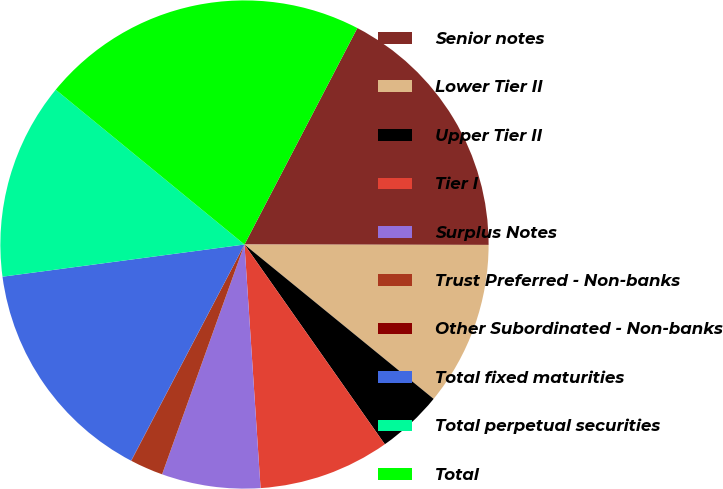Convert chart to OTSL. <chart><loc_0><loc_0><loc_500><loc_500><pie_chart><fcel>Senior notes<fcel>Lower Tier II<fcel>Upper Tier II<fcel>Tier I<fcel>Surplus Notes<fcel>Trust Preferred - Non-banks<fcel>Other Subordinated - Non-banks<fcel>Total fixed maturities<fcel>Total perpetual securities<fcel>Total<nl><fcel>17.38%<fcel>10.87%<fcel>4.36%<fcel>8.7%<fcel>6.53%<fcel>2.19%<fcel>0.02%<fcel>15.21%<fcel>13.04%<fcel>21.72%<nl></chart> 